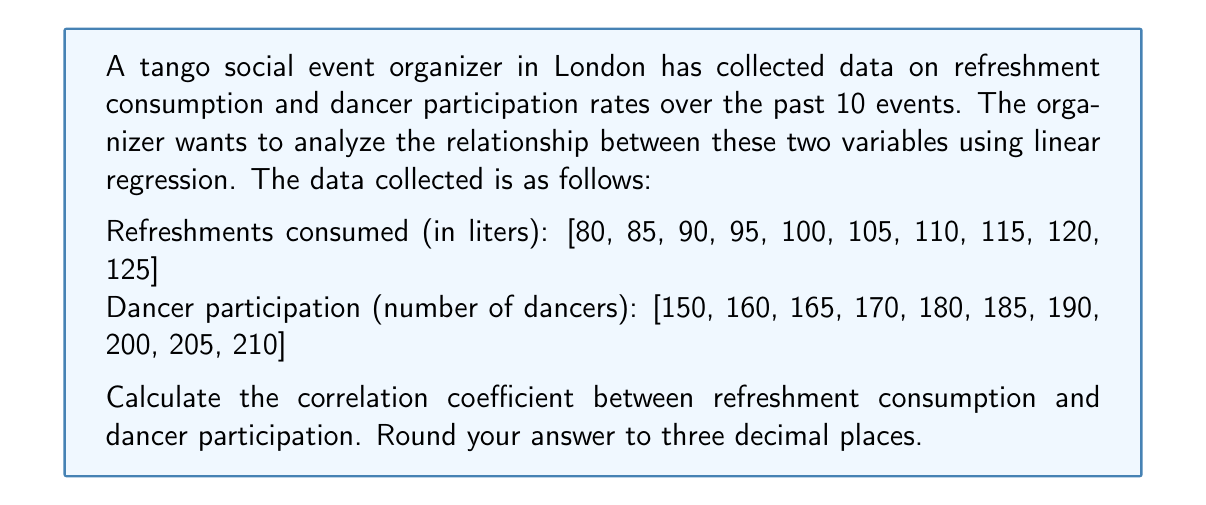Could you help me with this problem? To calculate the correlation coefficient, we'll use the formula:

$$ r = \frac{n\sum xy - \sum x \sum y}{\sqrt{[n\sum x^2 - (\sum x)^2][n\sum y^2 - (\sum y)^2]}} $$

Where:
$x$ = refreshment consumption
$y$ = dancer participation
$n$ = number of data points (10 in this case)

Step 1: Calculate the necessary sums:
$\sum x = 1025$
$\sum y = 1815$
$\sum xy = 188,275$
$\sum x^2 = 107,625$
$\sum y^2 = 332,725$

Step 2: Substitute these values into the correlation coefficient formula:

$$ r = \frac{10(188,275) - (1025)(1815)}{\sqrt{[10(107,625) - (1025)^2][10(332,725) - (1815)^2]}} $$

Step 3: Simplify the numerator and denominator:

$$ r = \frac{1,882,750 - 1,860,375}{\sqrt{(1,076,250 - 1,050,625)(3,327,250 - 3,294,225)}} $$

$$ r = \frac{22,375}{\sqrt{(25,625)(33,025)}} $$

Step 4: Calculate the final result:

$$ r = \frac{22,375}{\sqrt{846,015,625}} = \frac{22,375}{29,086.79} \approx 0.769 $$
Answer: 0.769 